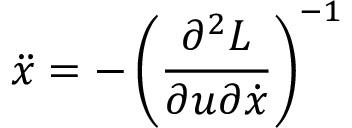Convert formula to latex. <formula><loc_0><loc_0><loc_500><loc_500>\ddot { x } = - \left ( \frac { \partial ^ { 2 } L } { \partial u \partial \dot { x } } \right ) ^ { - 1 }</formula> 